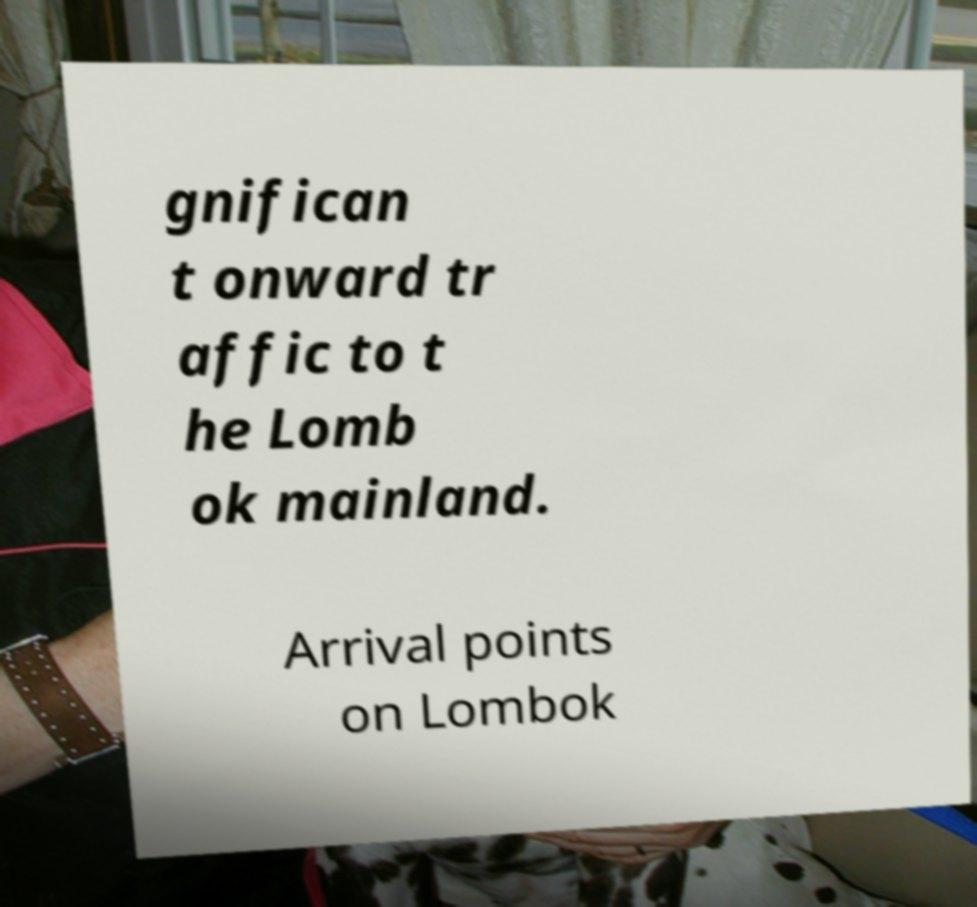Please read and relay the text visible in this image. What does it say? gnifican t onward tr affic to t he Lomb ok mainland. Arrival points on Lombok 